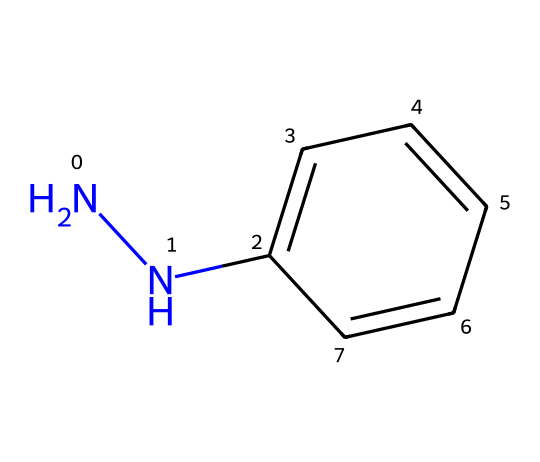What is the molecular formula of phenylhydrazine? The SMILES representation indicates the atoms present in the molecule: there are six carbon atoms (C), eight hydrogen atoms (H), and two nitrogen atoms (N). Therefore, the molecular formula can be deduced as C6H8N2.
Answer: C6H8N2 How many nitrogen atoms are in this structure? By analyzing the SMILES notation, we see the letters "N" twice, indicating that there are two nitrogen atoms in the structure.
Answer: 2 How many carbon atoms are part of the aromatic ring? The structure includes a benzene ring represented by the "C1=CC=CC=C1" part in the SMILES notation; this indicates that there are six carbon atoms in this aromatic ring.
Answer: 6 What functional group is present in phenylhydrazine? The presence of the "N-N" bond (the two nitrogen atoms connected) is characteristic of hydrazines, identifying the hydrazine functional group within the structure.
Answer: hydrazine What type of compound is phenylhydrazine classified as? Given the structure includes both nitrogen and carbon in a specific arrangement typical for aromatic compounds, phenylhydrazine can be classified as an aromatic hydrazine.
Answer: aromatic hydrazine What type of bonding is primarily found between the carbon and nitrogen in phenylhydrazine? The bonds between carbon and nitrogen in phenylhydrazine are primarily single covalent bonds, marked by the absence of additional double or triple bonds between them in the structure.
Answer: single covalent bonds Which part of the molecule varies in hydrazine derivatives? In hydrazine derivatives, the part that varies primarily involves the phenyl group, where different substituents can be added to produce various derivatives of hydrazines.
Answer: phenyl group 